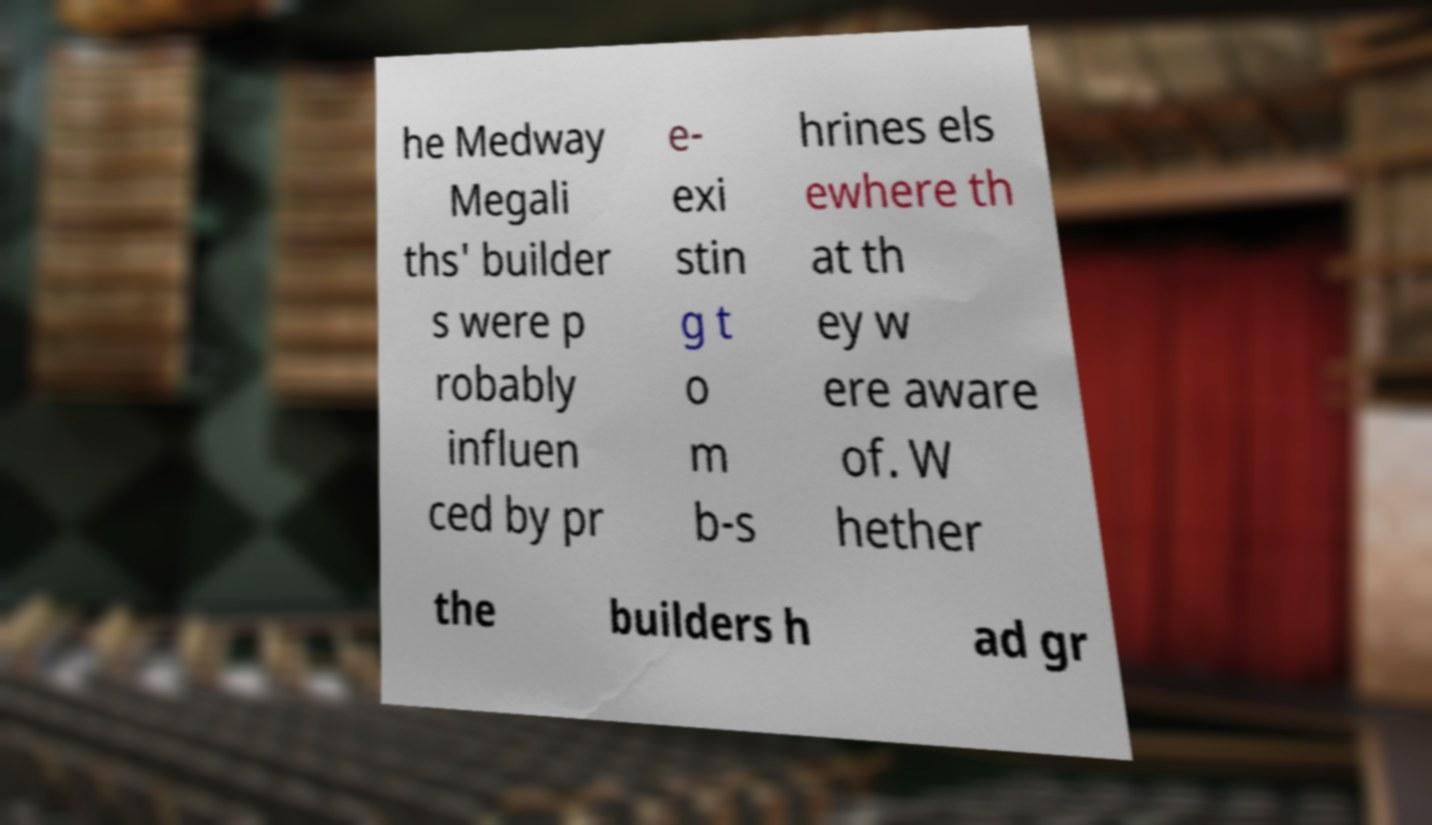Can you accurately transcribe the text from the provided image for me? he Medway Megali ths' builder s were p robably influen ced by pr e- exi stin g t o m b-s hrines els ewhere th at th ey w ere aware of. W hether the builders h ad gr 